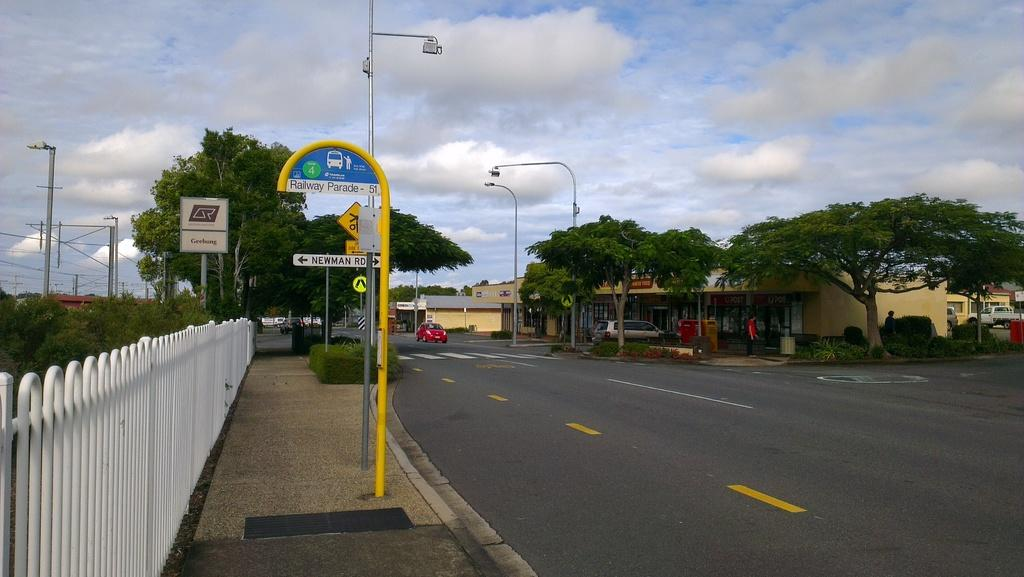Provide a one-sentence caption for the provided image. A bus stop with the sign "Railway Parade." sits across the street from a small store. 